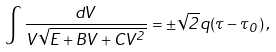Convert formula to latex. <formula><loc_0><loc_0><loc_500><loc_500>\int { \frac { d V } { V \sqrt { E + B V + C V ^ { 2 } } } } = \pm \sqrt { 2 } q ( \tau - \tau _ { 0 } ) \, ,</formula> 